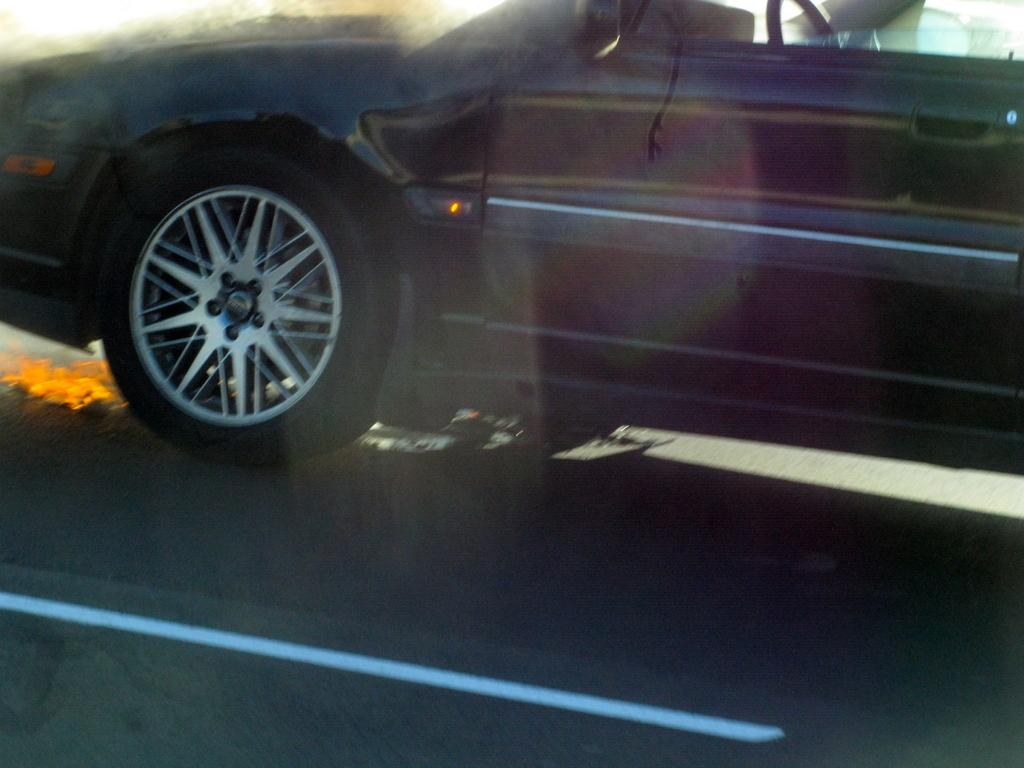What is the color of the car in the image? The car in the image is black. What is the car doing in the image? The car is moving on a road. What type of plot is the car driving through in the image? There is no specific plot mentioned in the image; it only shows a black car moving on a road. What kind of patch can be seen on the car's hood in the image? There is no patch visible on the car's hood in the image. 